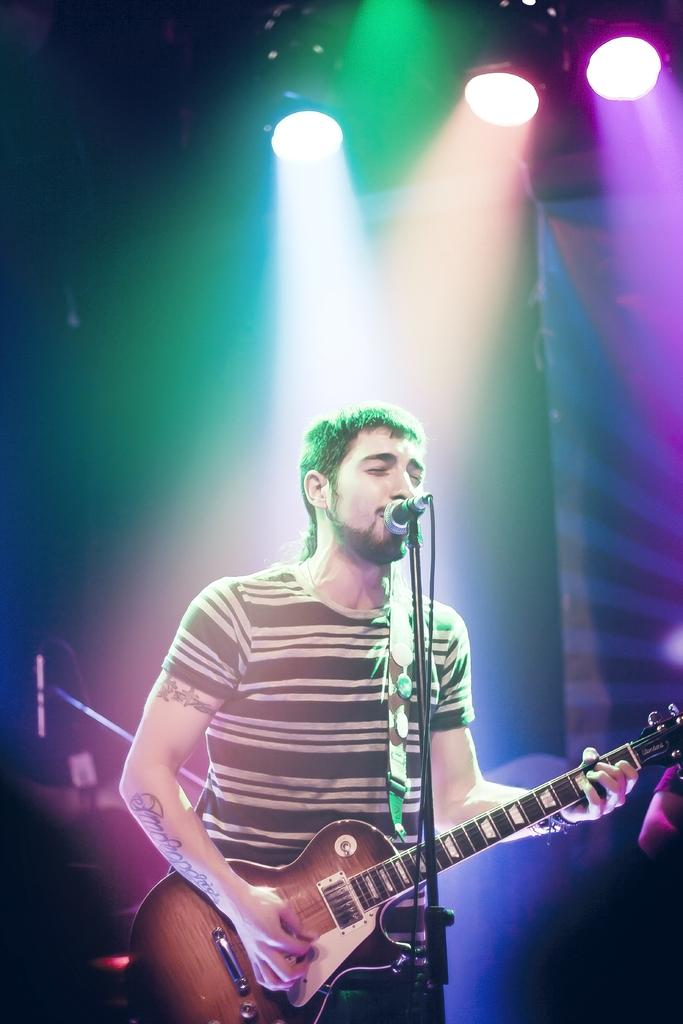What is the man in the image doing? The man is playing a guitar and singing. How is the man's voice being amplified in the image? The man is using a microphone. What can be seen in the background of the image? There are lights visible in the image. How does the man increase the size of the hill in the image? There is no hill present in the image, so it cannot be increased in size. 